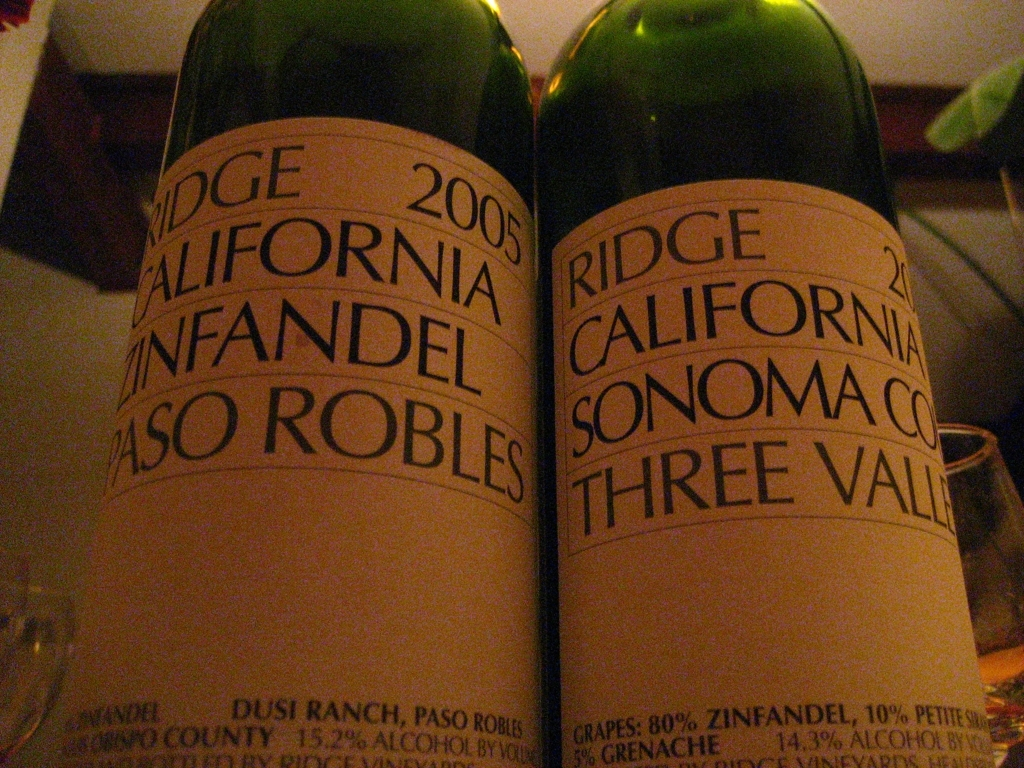What can you infer about the vintage and its impact on the wine's quality? The image displays bottles from 2005 and 2006. Wines from specific vintages in California can vary greatly due to fluctuating climatic conditions each year. A 2005 vintage from Paso Robles typically signals a very good year with favorable weather conditions leading to well-structured wines with potential for aging. The 2006 vintage in Sonoma might suggest a slightly more challenging year but still produces wines with distinct character and appeal. 